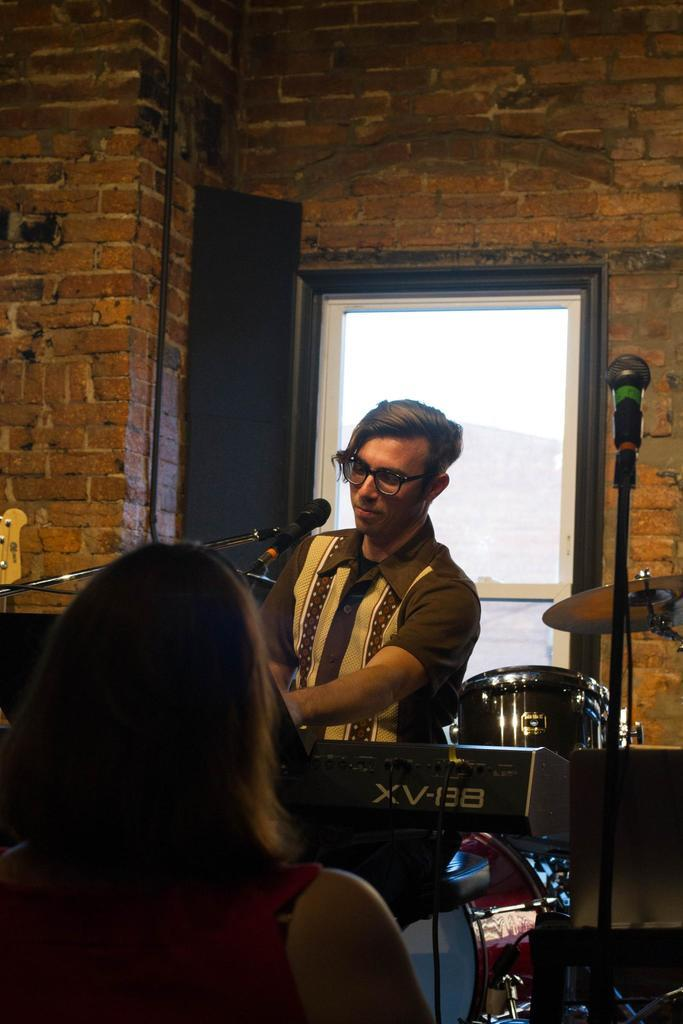How many people are present in the image? There are two people in the image. What objects are associated with the people in the image? There are microphones with stands in the image. What type of object can be seen in the image that is related to music? There is a musical instrument in the image. What electronic device is visible in the image? There is a device in the image. What can be seen in the background of the image? There is a wall and glass in the background of the image. What language are the people exchanging in the image? There is no indication of a language exchange in the image, as the focus is on the microphones, musical instrument, and device. 